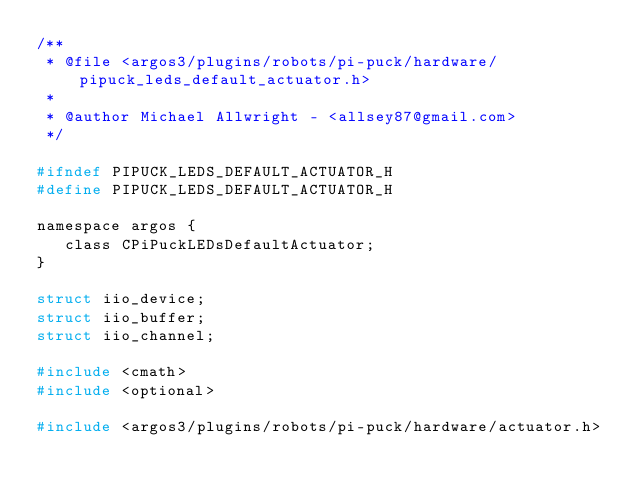<code> <loc_0><loc_0><loc_500><loc_500><_C_>/**
 * @file <argos3/plugins/robots/pi-puck/hardware/pipuck_leds_default_actuator.h>
 *
 * @author Michael Allwright - <allsey87@gmail.com>
 */

#ifndef PIPUCK_LEDS_DEFAULT_ACTUATOR_H
#define PIPUCK_LEDS_DEFAULT_ACTUATOR_H

namespace argos {
   class CPiPuckLEDsDefaultActuator;
}

struct iio_device;
struct iio_buffer;
struct iio_channel; 

#include <cmath>
#include <optional>

#include <argos3/plugins/robots/pi-puck/hardware/actuator.h></code> 